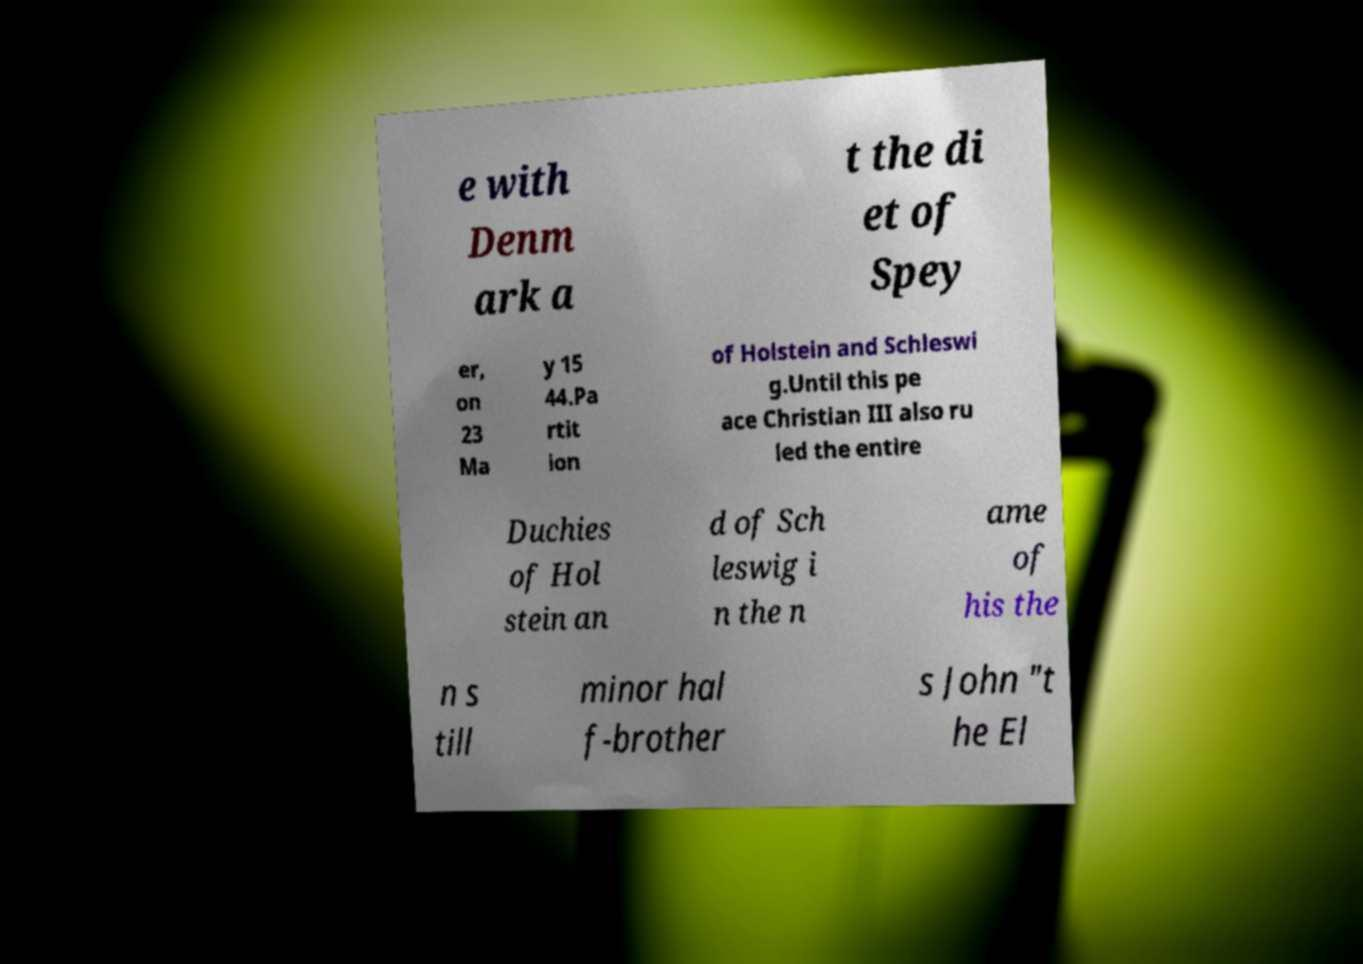There's text embedded in this image that I need extracted. Can you transcribe it verbatim? e with Denm ark a t the di et of Spey er, on 23 Ma y 15 44.Pa rtit ion of Holstein and Schleswi g.Until this pe ace Christian III also ru led the entire Duchies of Hol stein an d of Sch leswig i n the n ame of his the n s till minor hal f-brother s John "t he El 